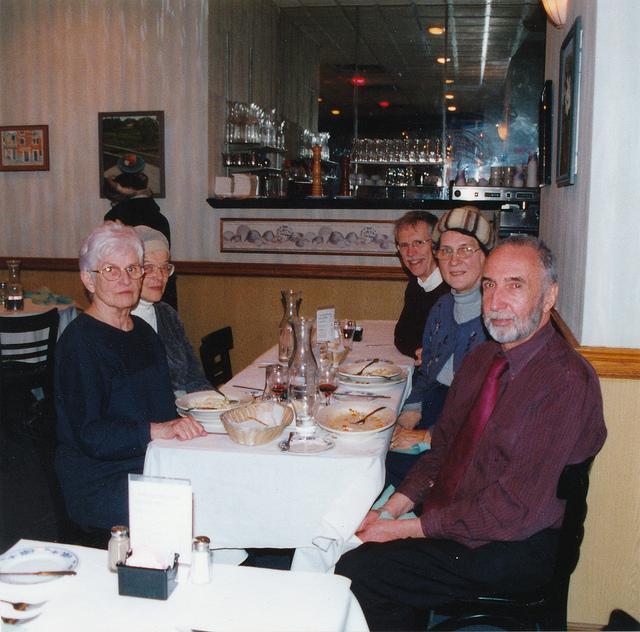How many people are in the photo?
Give a very brief answer. 6. How many people are looking at the camera?
Give a very brief answer. 5. How many candles are in the picture?
Give a very brief answer. 0. How many wines bottles are here?
Give a very brief answer. 0. How many men are at the table?
Give a very brief answer. 2. How many bowls can you see?
Give a very brief answer. 2. How many people are there?
Give a very brief answer. 6. How many chairs can be seen?
Give a very brief answer. 2. How many dining tables are there?
Give a very brief answer. 3. How many of the people sitting have a laptop on there lap?
Give a very brief answer. 0. 